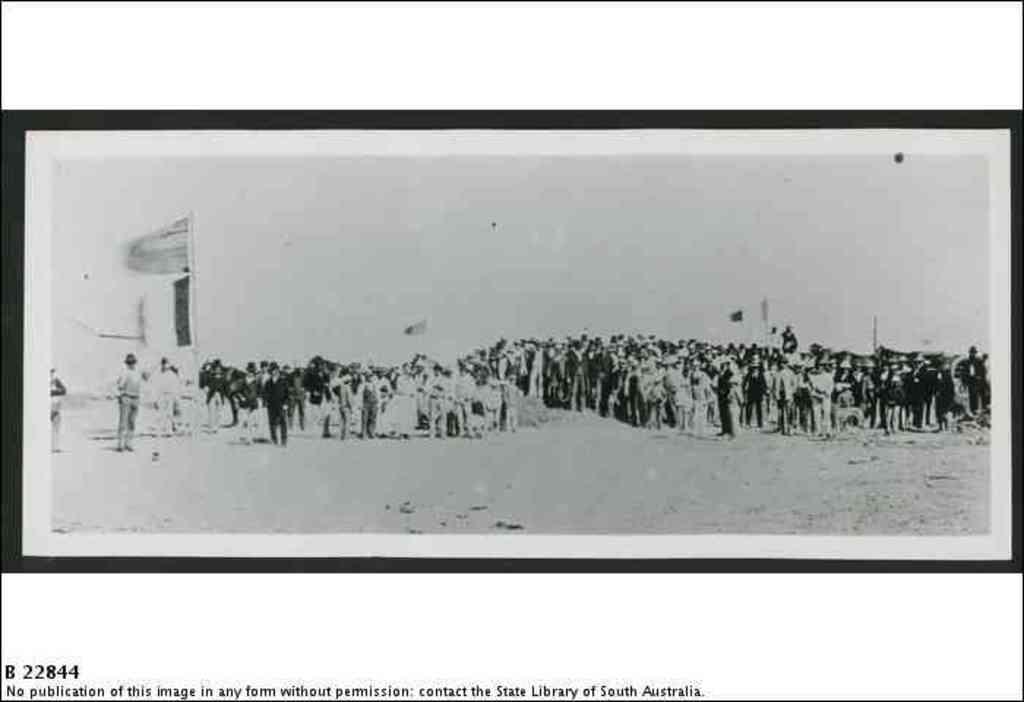Where was this picture taken?
Provide a short and direct response. South australia. 